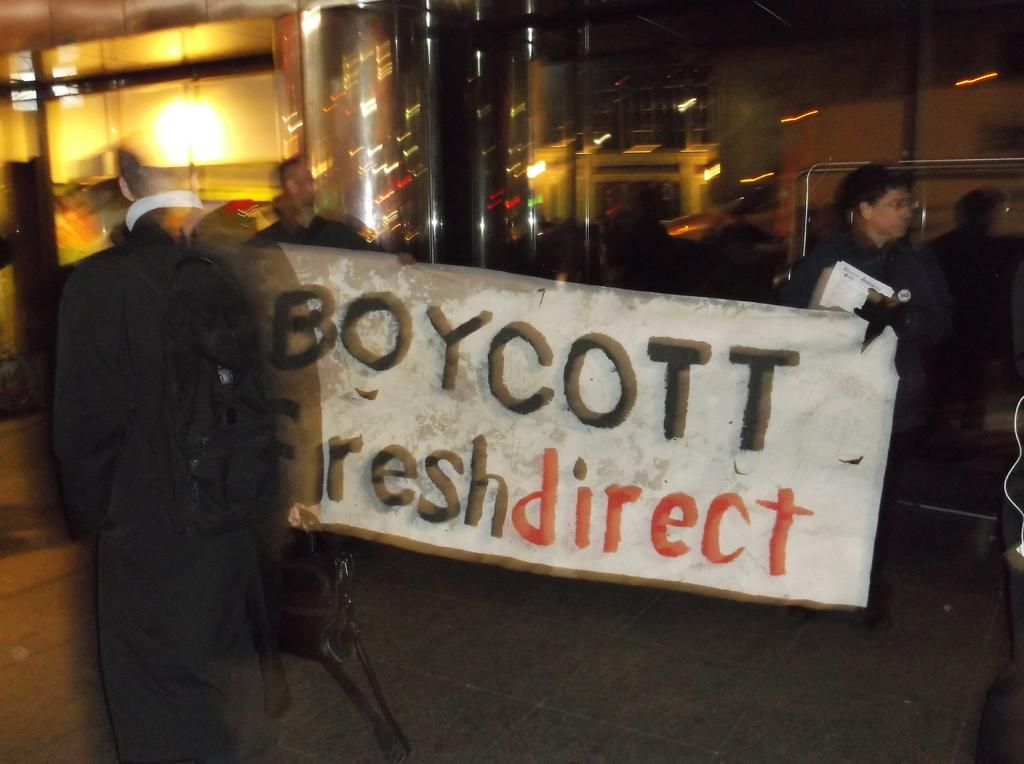What is the person in the image wearing? The person is wearing a black dress. What is the person holding in the image? The person is holding a bag. What is the color of the bag the person is holding? The bag is not explicitly described as a specific color, but it is mentioned that there is a bag in the image. What is visible in the background of the image? There are people visible in the background of the image. What type of object can be seen in the image, which is typically used for writing or displaying information? There is a white board in the image. What type of lighting is present in the image? There are yellow lights in the image. How many holes can be seen in the person's dress in the image? There is no mention of any holes in the person's dress in the image. What type of tax is being discussed on the white board in the image? There is no mention of any tax-related information on the white board in the image. 